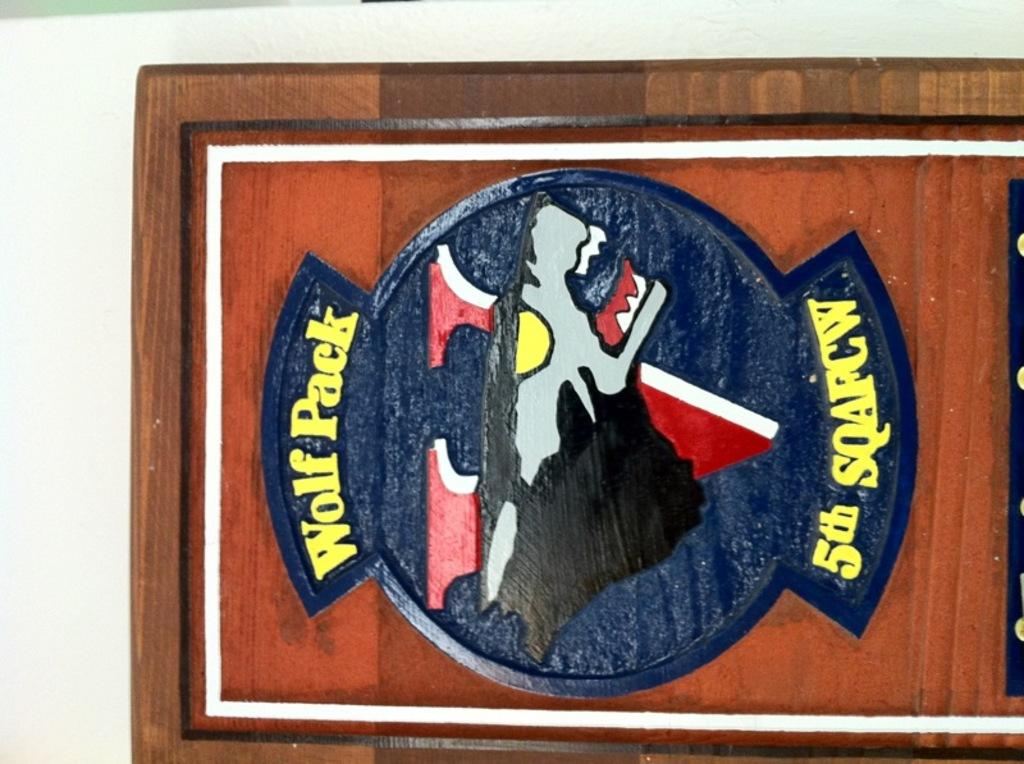Provide a one-sentence caption for the provided image. a plaque reading Wolf Pack 5th Squafcw on a white wall. 